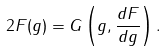Convert formula to latex. <formula><loc_0><loc_0><loc_500><loc_500>2 F ( g ) = G \left ( g , \frac { d F } { d g } \right ) .</formula> 